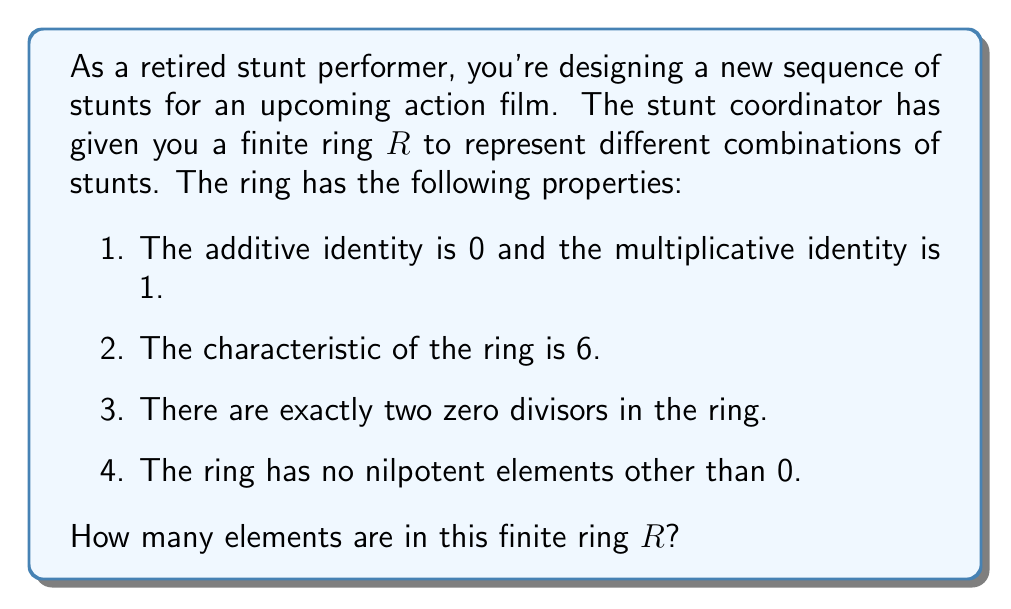Can you answer this question? Let's approach this step-by-step:

1) First, we know that the characteristic of the ring is 6. This means that for any element $a$ in the ring, $6a = 0$. 

2) The fact that the characteristic is 6 implies that the ring must have at least 6 elements: $\{0, 1, 2, 3, 4, 5\}$ under addition modulo 6.

3) We're told there are exactly two zero divisors in the ring. In a ring of 6 elements, the zero divisors would be 2 and 3, as $2 \times 3 = 0$ in modulo 6 arithmetic.

4) The ring has no nilpotent elements other than 0. In a ring of 6 elements, 2 and 3 would be nilpotent ($2^3 = 0$ and $3^2 = 0$ in modulo 6). Since we're told there are no nilpotent elements other than 0, the ring cannot have just 6 elements.

5) The next possibility is a ring with 12 elements. In modular arithmetic, we can represent this as $\mathbb{Z}_{12}$. However, $\mathbb{Z}_{12}$ has four zero divisors (3, 4, 6, and 9), which doesn't match our conditions.

6) The next option is a ring with 18 elements. We can represent this as $\mathbb{Z}_6[x]/(x^3)$, which is the ring of polynomials over $\mathbb{Z}_6$ modulo $x^3$.

7) In this ring:
   - The characteristic is 6, as required.
   - There are exactly two zero divisors: $2x$ and $3x$.
   - There are no nilpotent elements other than 0, as $x^3 = 0$ in this ring.

Therefore, the ring $R$ must have 18 elements.
Answer: The finite ring $R$ has 18 elements. 